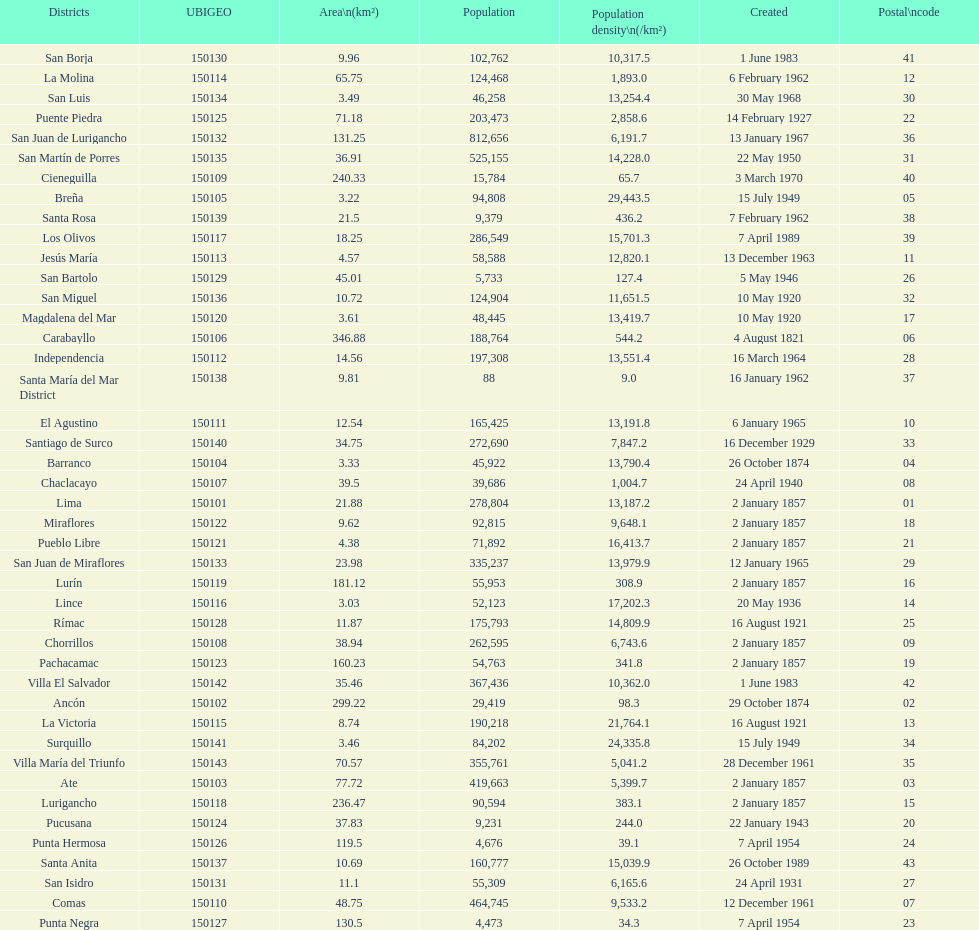Can you give me this table as a dict? {'header': ['Districts', 'UBIGEO', 'Area\\n(km²)', 'Population', 'Population density\\n(/km²)', 'Created', 'Postal\\ncode'], 'rows': [['San Borja', '150130', '9.96', '102,762', '10,317.5', '1 June 1983', '41'], ['La Molina', '150114', '65.75', '124,468', '1,893.0', '6 February 1962', '12'], ['San Luis', '150134', '3.49', '46,258', '13,254.4', '30 May 1968', '30'], ['Puente Piedra', '150125', '71.18', '203,473', '2,858.6', '14 February 1927', '22'], ['San Juan de Lurigancho', '150132', '131.25', '812,656', '6,191.7', '13 January 1967', '36'], ['San Martín de Porres', '150135', '36.91', '525,155', '14,228.0', '22 May 1950', '31'], ['Cieneguilla', '150109', '240.33', '15,784', '65.7', '3 March 1970', '40'], ['Breña', '150105', '3.22', '94,808', '29,443.5', '15 July 1949', '05'], ['Santa Rosa', '150139', '21.5', '9,379', '436.2', '7 February 1962', '38'], ['Los Olivos', '150117', '18.25', '286,549', '15,701.3', '7 April 1989', '39'], ['Jesús María', '150113', '4.57', '58,588', '12,820.1', '13 December 1963', '11'], ['San Bartolo', '150129', '45.01', '5,733', '127.4', '5 May 1946', '26'], ['San Miguel', '150136', '10.72', '124,904', '11,651.5', '10 May 1920', '32'], ['Magdalena del Mar', '150120', '3.61', '48,445', '13,419.7', '10 May 1920', '17'], ['Carabayllo', '150106', '346.88', '188,764', '544.2', '4 August 1821', '06'], ['Independencia', '150112', '14.56', '197,308', '13,551.4', '16 March 1964', '28'], ['Santa María del Mar District', '150138', '9.81', '88', '9.0', '16 January 1962', '37'], ['El Agustino', '150111', '12.54', '165,425', '13,191.8', '6 January 1965', '10'], ['Santiago de Surco', '150140', '34.75', '272,690', '7,847.2', '16 December 1929', '33'], ['Barranco', '150104', '3.33', '45,922', '13,790.4', '26 October 1874', '04'], ['Chaclacayo', '150107', '39.5', '39,686', '1,004.7', '24 April 1940', '08'], ['Lima', '150101', '21.88', '278,804', '13,187.2', '2 January 1857', '01'], ['Miraflores', '150122', '9.62', '92,815', '9,648.1', '2 January 1857', '18'], ['Pueblo Libre', '150121', '4.38', '71,892', '16,413.7', '2 January 1857', '21'], ['San Juan de Miraflores', '150133', '23.98', '335,237', '13,979.9', '12 January 1965', '29'], ['Lurín', '150119', '181.12', '55,953', '308.9', '2 January 1857', '16'], ['Lince', '150116', '3.03', '52,123', '17,202.3', '20 May 1936', '14'], ['Rímac', '150128', '11.87', '175,793', '14,809.9', '16 August 1921', '25'], ['Chorrillos', '150108', '38.94', '262,595', '6,743.6', '2 January 1857', '09'], ['Pachacamac', '150123', '160.23', '54,763', '341.8', '2 January 1857', '19'], ['Villa El Salvador', '150142', '35.46', '367,436', '10,362.0', '1 June 1983', '42'], ['Ancón', '150102', '299.22', '29,419', '98.3', '29 October 1874', '02'], ['La Victoria', '150115', '8.74', '190,218', '21,764.1', '16 August 1921', '13'], ['Surquillo', '150141', '3.46', '84,202', '24,335.8', '15 July 1949', '34'], ['Villa María del Triunfo', '150143', '70.57', '355,761', '5,041.2', '28 December 1961', '35'], ['Ate', '150103', '77.72', '419,663', '5,399.7', '2 January 1857', '03'], ['Lurigancho', '150118', '236.47', '90,594', '383.1', '2 January 1857', '15'], ['Pucusana', '150124', '37.83', '9,231', '244.0', '22 January 1943', '20'], ['Punta Hermosa', '150126', '119.5', '4,676', '39.1', '7 April 1954', '24'], ['Santa Anita', '150137', '10.69', '160,777', '15,039.9', '26 October 1989', '43'], ['San Isidro', '150131', '11.1', '55,309', '6,165.6', '24 April 1931', '27'], ['Comas', '150110', '48.75', '464,745', '9,533.2', '12 December 1961', '07'], ['Punta Negra', '150127', '130.5', '4,473', '34.3', '7 April 1954', '23']]} How many districts are there in this city? 43. 